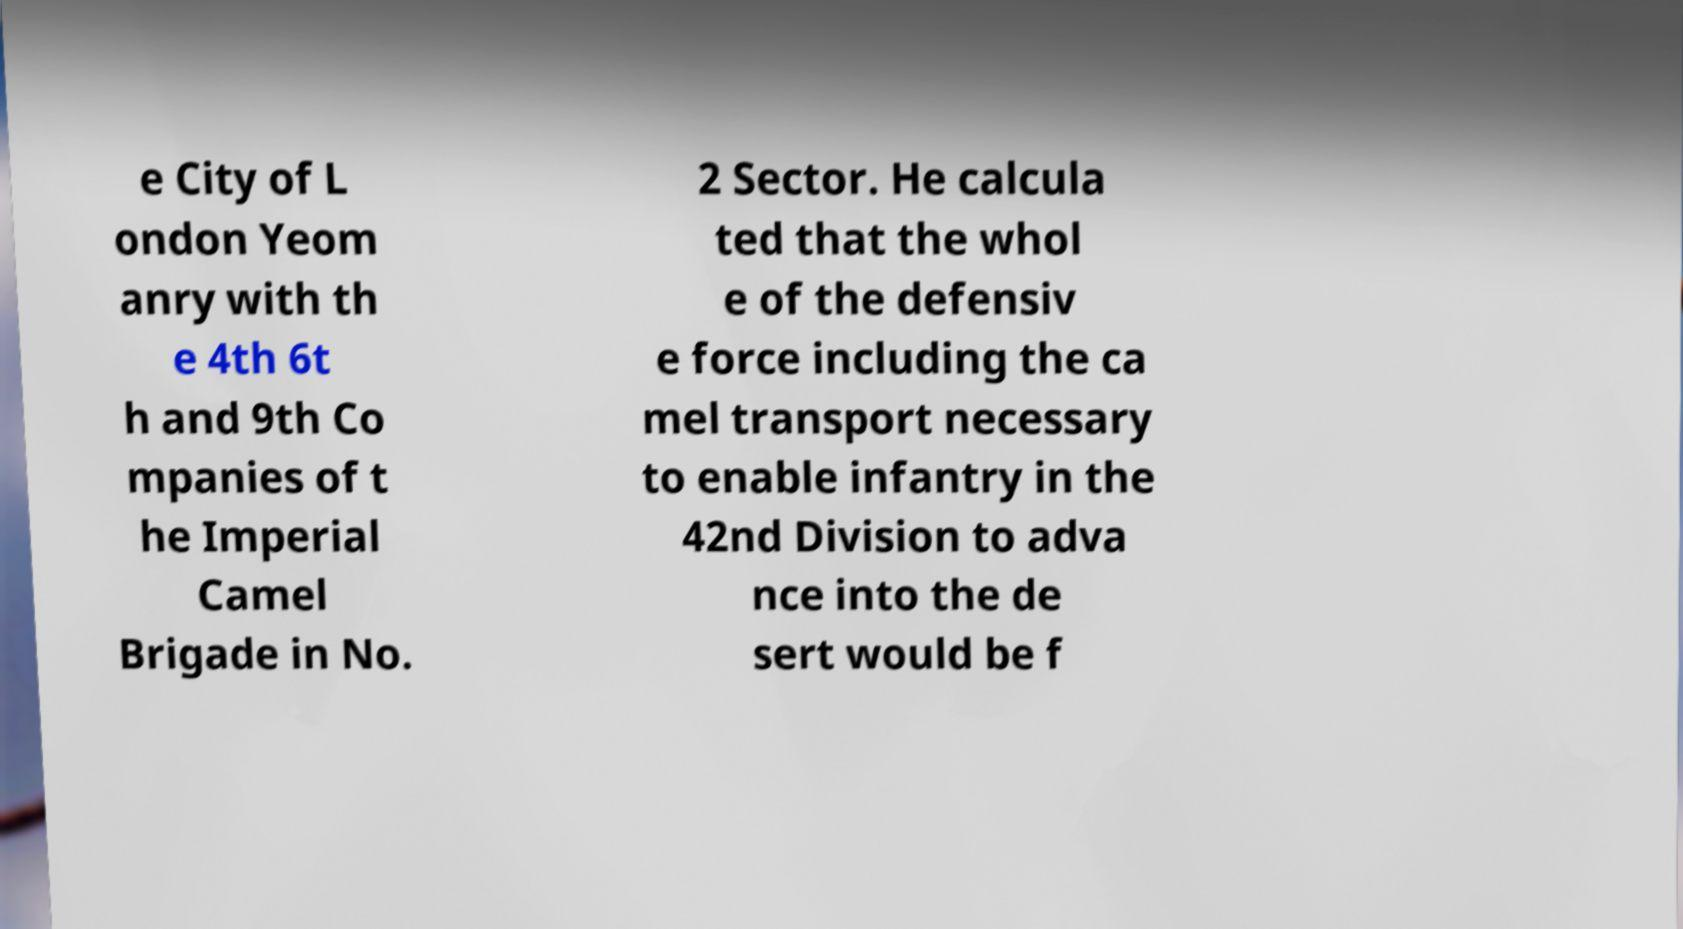Please identify and transcribe the text found in this image. e City of L ondon Yeom anry with th e 4th 6t h and 9th Co mpanies of t he Imperial Camel Brigade in No. 2 Sector. He calcula ted that the whol e of the defensiv e force including the ca mel transport necessary to enable infantry in the 42nd Division to adva nce into the de sert would be f 